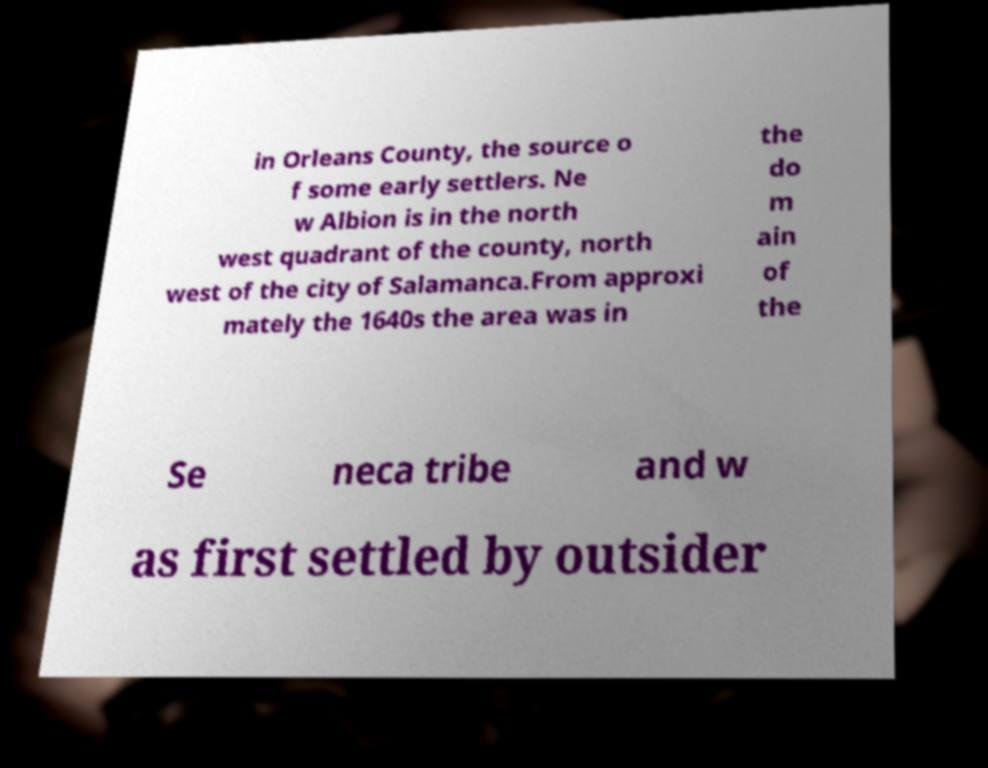For documentation purposes, I need the text within this image transcribed. Could you provide that? in Orleans County, the source o f some early settlers. Ne w Albion is in the north west quadrant of the county, north west of the city of Salamanca.From approxi mately the 1640s the area was in the do m ain of the Se neca tribe and w as first settled by outsider 